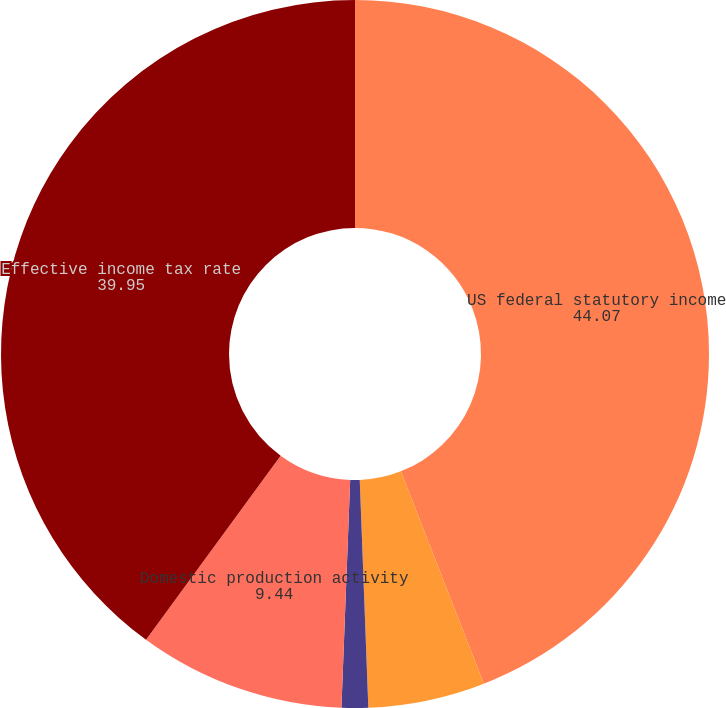<chart> <loc_0><loc_0><loc_500><loc_500><pie_chart><fcel>US federal statutory income<fcel>State and local income taxes<fcel>Effect of foreign operations<fcel>Domestic production activity<fcel>Effective income tax rate<nl><fcel>44.07%<fcel>5.33%<fcel>1.21%<fcel>9.44%<fcel>39.95%<nl></chart> 